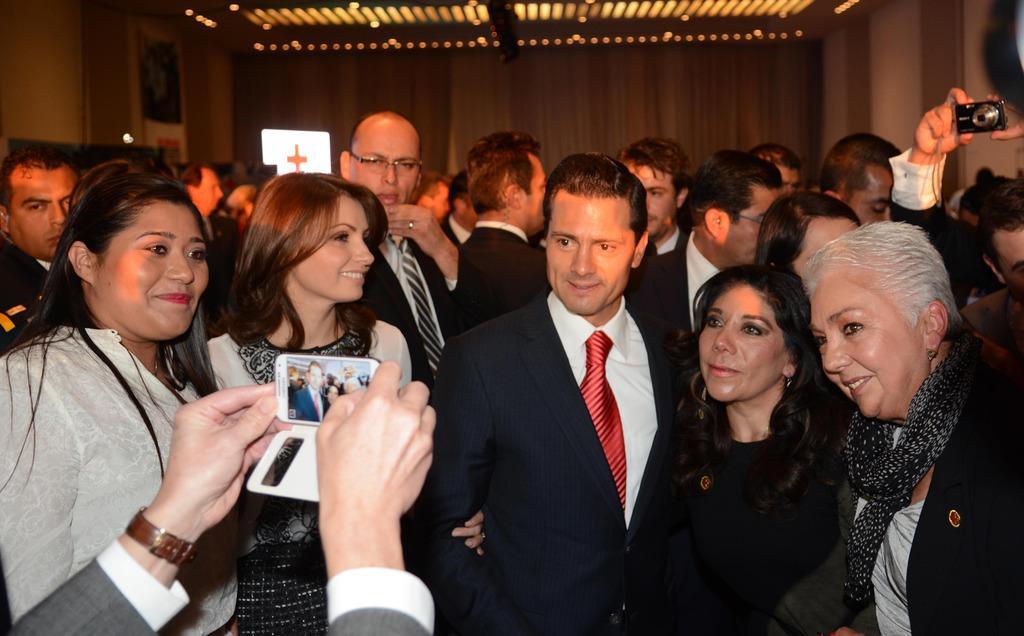Describe this image in one or two sentences. In front of the picture, we see four women and a man are standing. They are smiling and they are posing for the photo. In front of the picture, we see the hands of the person holding the mobile phone and he is clicking photos with the mobile phone. Behind them, we see many people are standing and we see the hands of the person holding the camera. In the background, we see a wall and the projector screen or a board in white color. At the top, we see the ceiling of the room. 